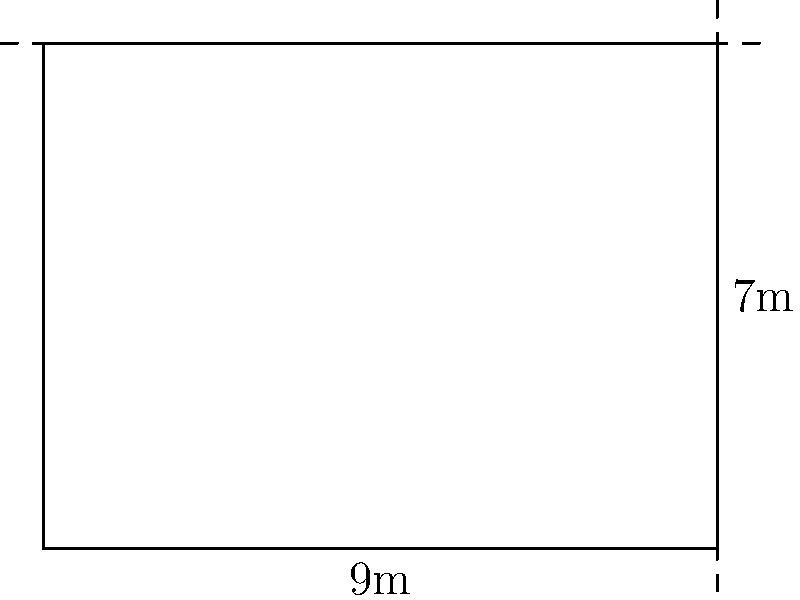A traditional Swedish log cabin in Kristdala has a rectangular base. The length of the cabin is 9 meters, and its width is 7 meters. Calculate the perimeter of the cabin's base. To calculate the perimeter of a rectangle, we need to add up the lengths of all four sides. In this case:

1. We have two lengths (long sides) of 9 meters each.
2. We have two widths (short sides) of 7 meters each.

The formula for the perimeter of a rectangle is:

$$P = 2l + 2w$$

Where $P$ is the perimeter, $l$ is the length, and $w$ is the width.

Let's substitute the values:

$$P = 2(9) + 2(7)$$
$$P = 18 + 14$$
$$P = 32$$

Therefore, the perimeter of the cabin's base is 32 meters.
Answer: 32 meters 